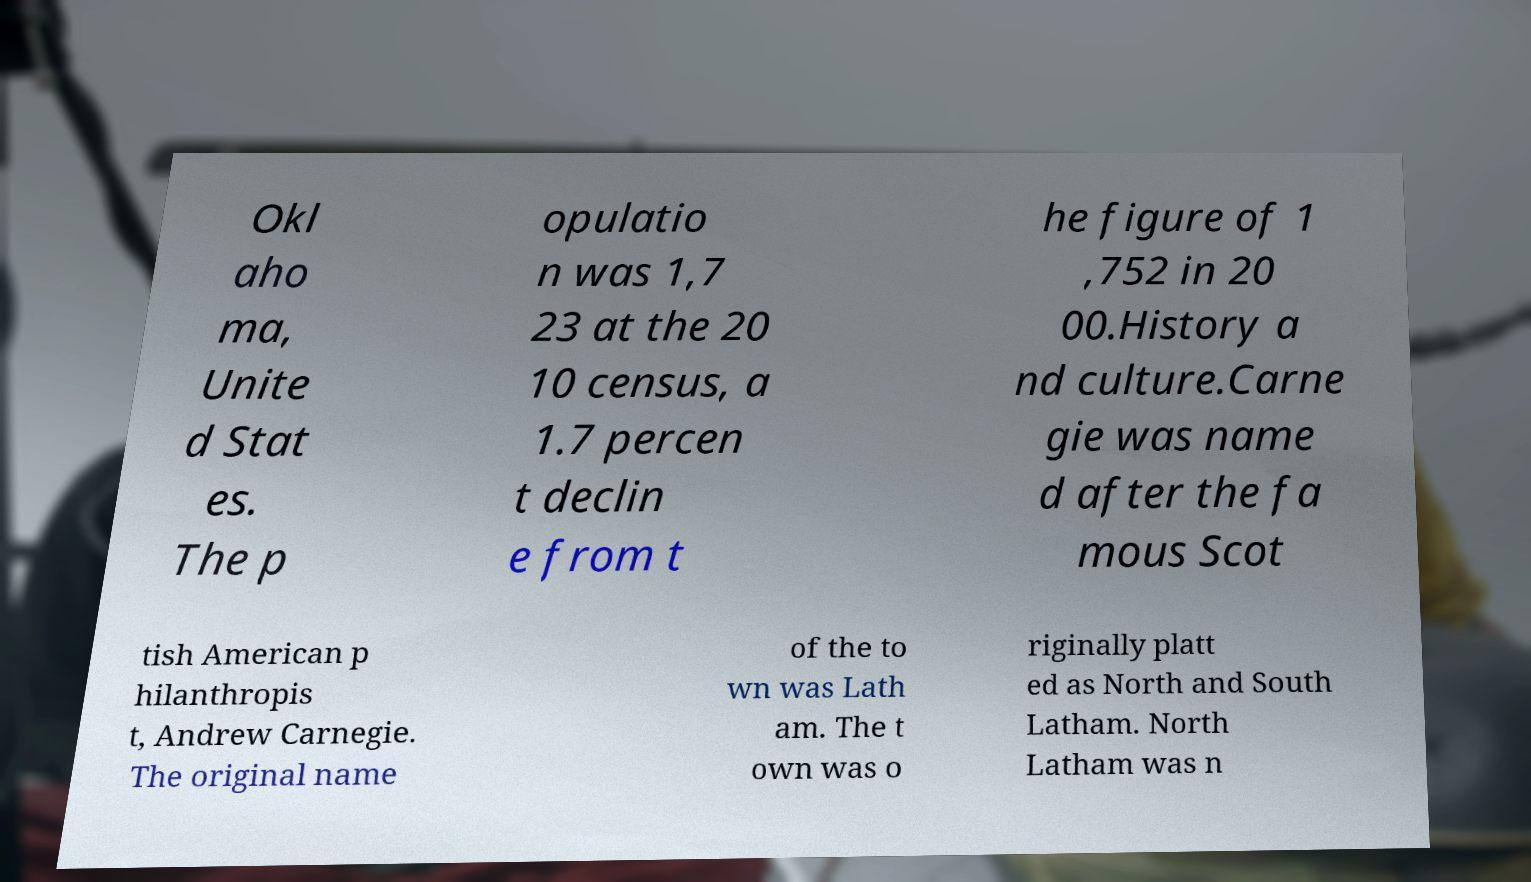Please read and relay the text visible in this image. What does it say? Okl aho ma, Unite d Stat es. The p opulatio n was 1,7 23 at the 20 10 census, a 1.7 percen t declin e from t he figure of 1 ,752 in 20 00.History a nd culture.Carne gie was name d after the fa mous Scot tish American p hilanthropis t, Andrew Carnegie. The original name of the to wn was Lath am. The t own was o riginally platt ed as North and South Latham. North Latham was n 